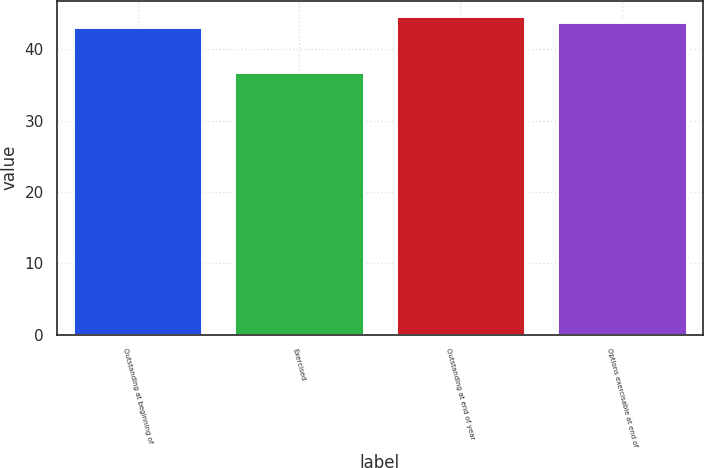Convert chart to OTSL. <chart><loc_0><loc_0><loc_500><loc_500><bar_chart><fcel>Outstanding at beginning of<fcel>Exercised<fcel>Outstanding at end of year<fcel>Options exercisable at end of<nl><fcel>43.05<fcel>36.84<fcel>44.59<fcel>43.82<nl></chart> 